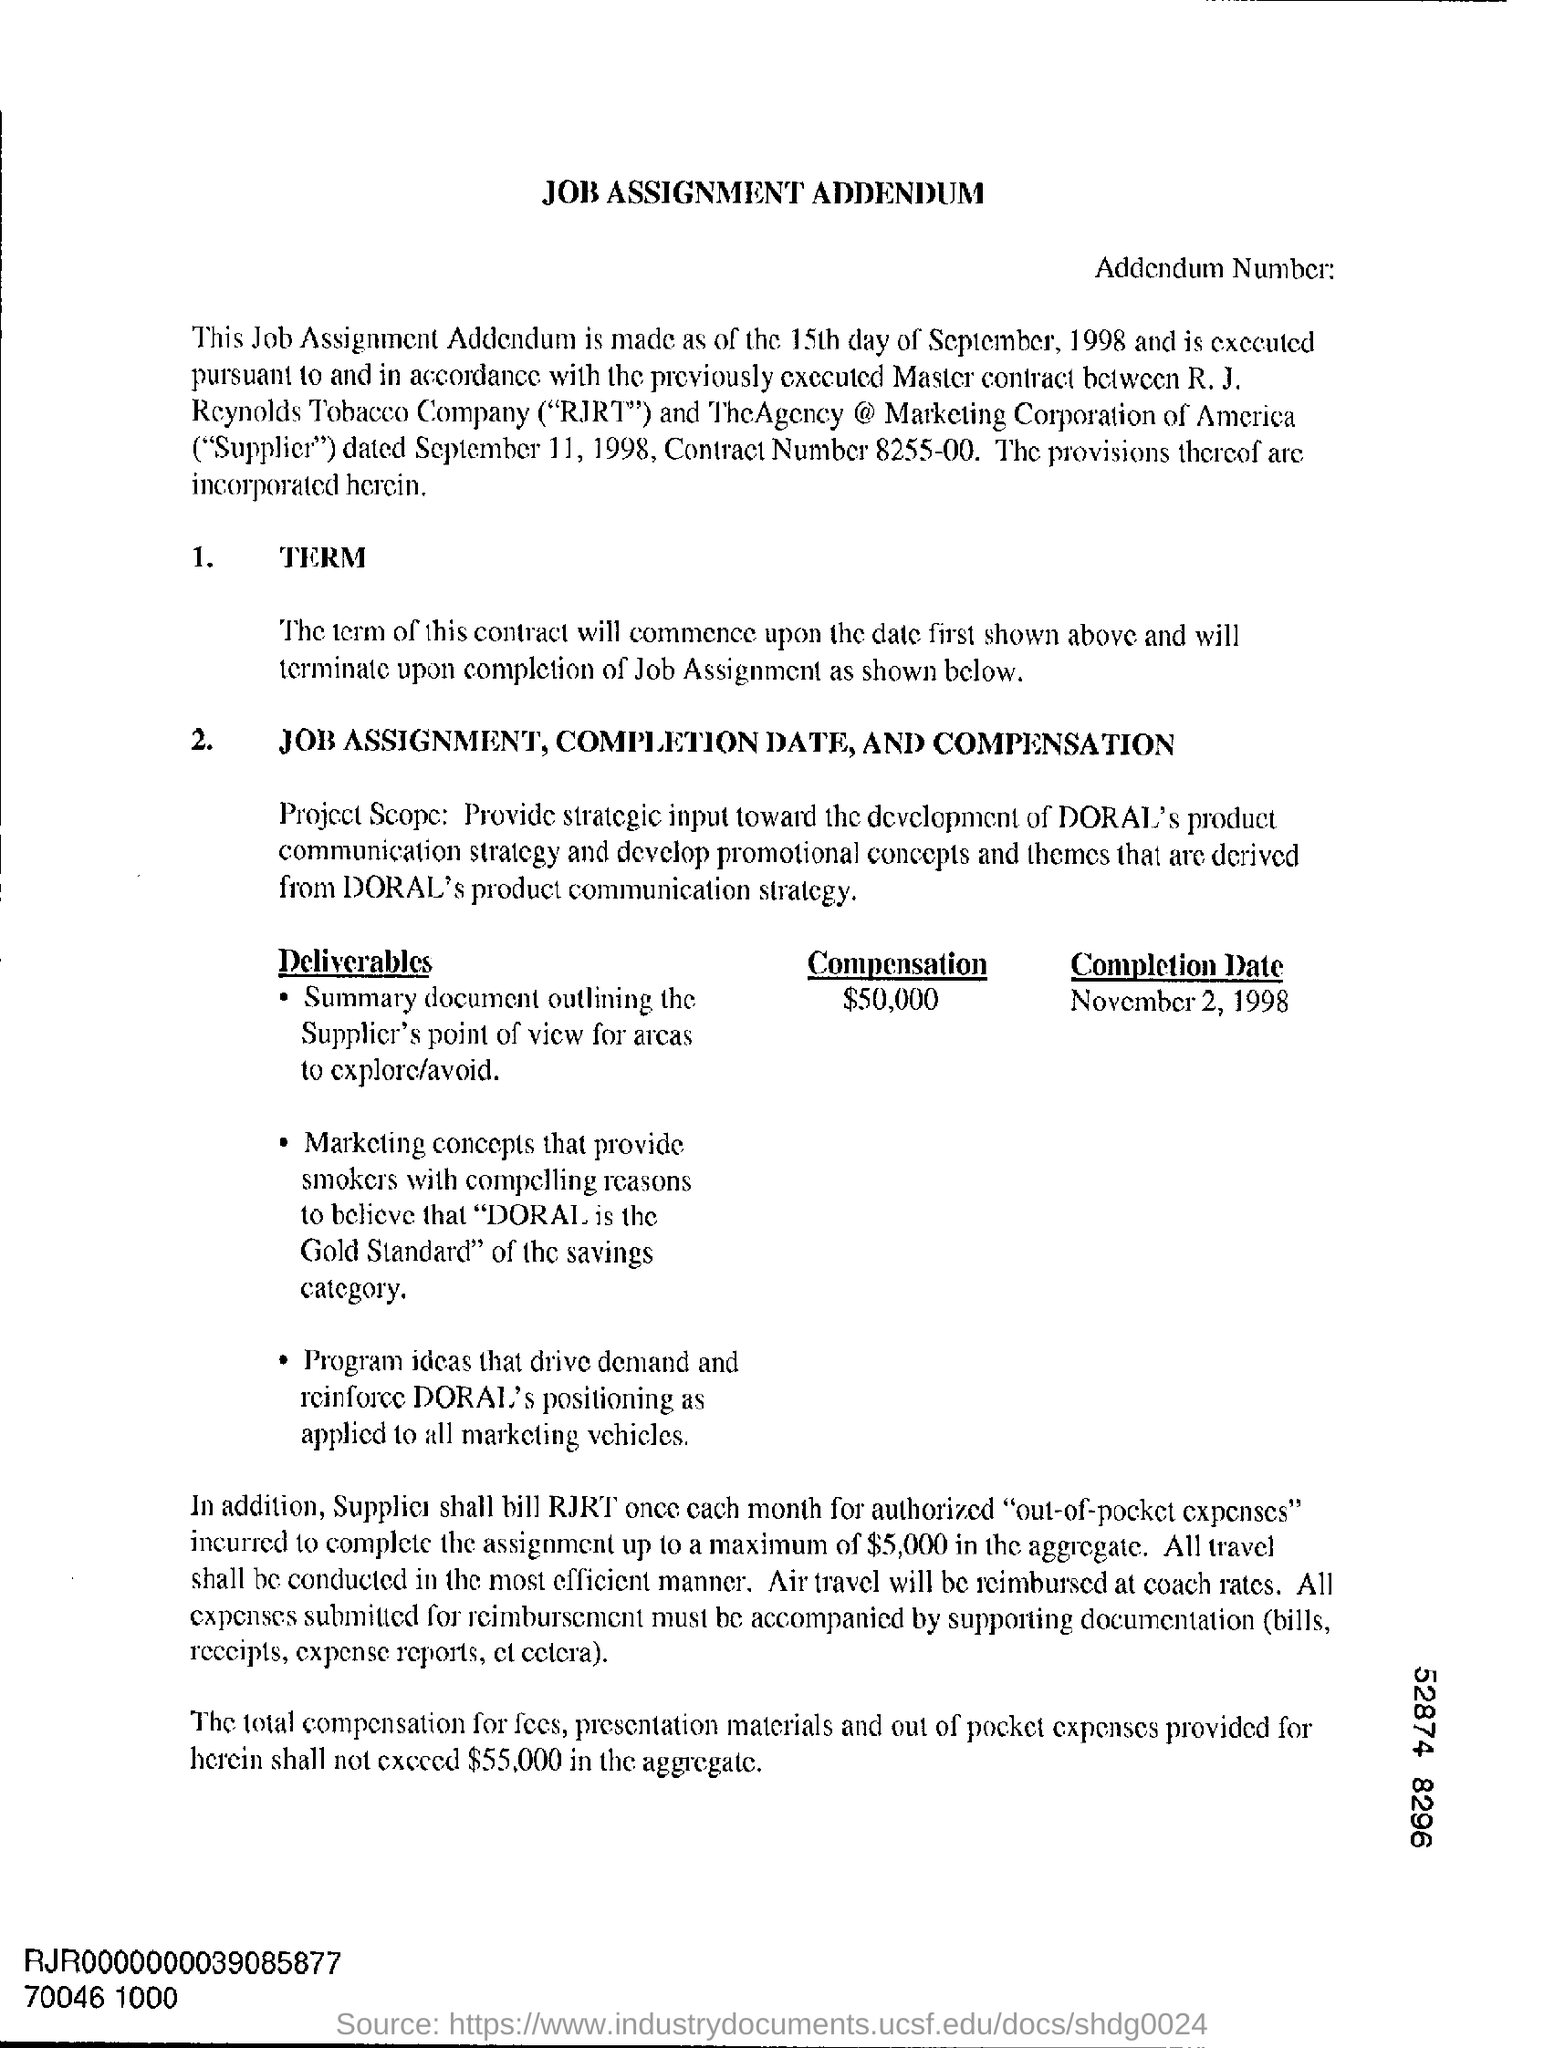Mention a couple of crucial points in this snapshot. The completion date is November 2, 1998. On the 15th day of September, 1998, the addendum was created. The heading of the document is 'Job Assignment Addendum.' 